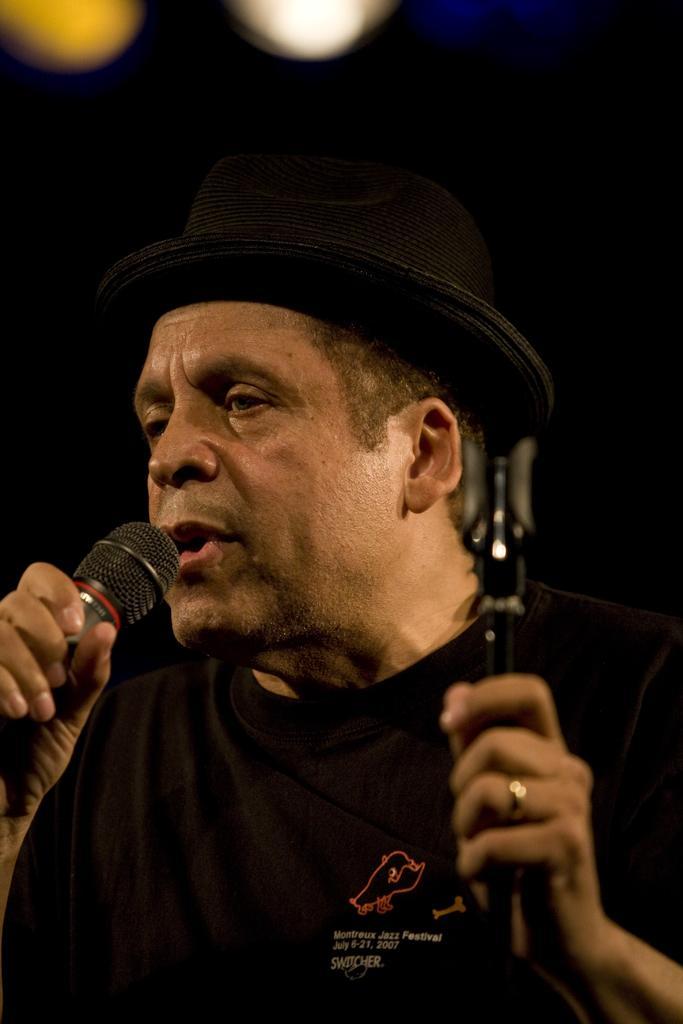In one or two sentences, can you explain what this image depicts? In this image we can see a man holding a mic and singing. 